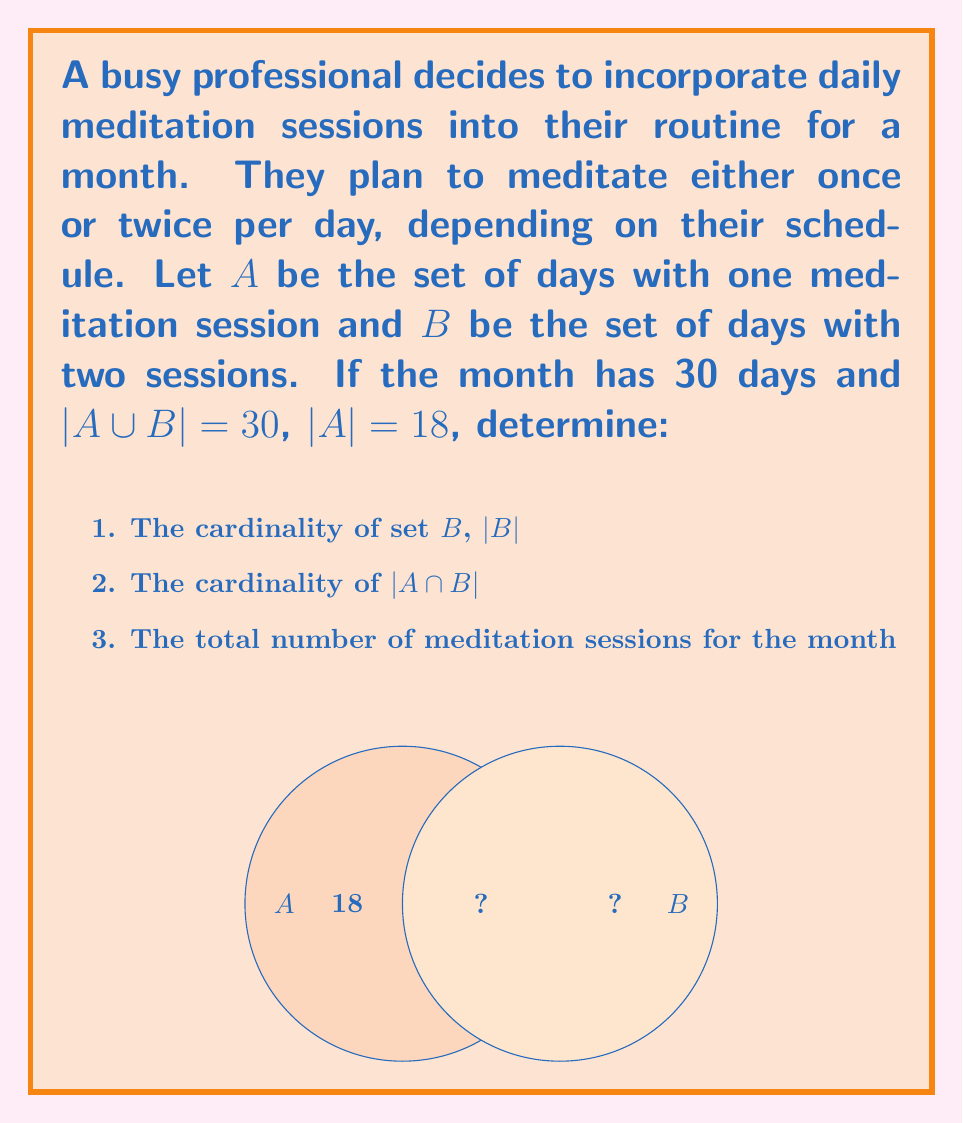Solve this math problem. Let's approach this step-by-step:

1. To find $|B|$:
   We know that $|A \cup B| = 30$ (total days in the month)
   And $|A| = 18$
   Using the principle of inclusion-exclusion:
   $|A \cup B| = |A| + |B| - |A \cap B|$
   $30 = 18 + |B| - |A \cap B|$
   $|B| = 30 - 18 + |A \cap B| = 12 + |A \cap B|$

2. To find $|A \cap B|$:
   Since A and B are disjoint (a day can't have both one and two sessions), $|A \cap B| = 0$

3. Now we can determine $|B|$:
   $|B| = 12 + 0 = 12$

4. Total number of meditation sessions:
   Days with one session: 18
   Days with two sessions: 12
   Total sessions = $18 \cdot 1 + 12 \cdot 2 = 18 + 24 = 42$

Therefore:
1. $|B| = 12$
2. $|A \cap B| = 0$
3. Total sessions = 42
Answer: 1. 12
2. 0
3. 42 